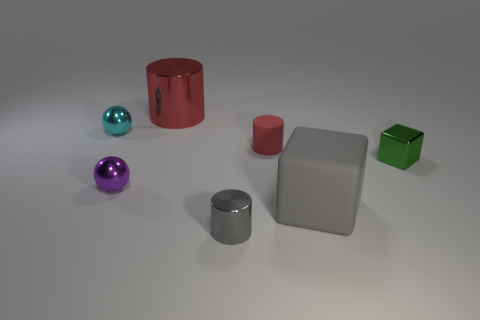Add 3 gray rubber objects. How many objects exist? 10 Subtract all blocks. How many objects are left? 5 Subtract 0 brown spheres. How many objects are left? 7 Subtract all tiny purple metallic things. Subtract all tiny purple metal balls. How many objects are left? 5 Add 1 small purple things. How many small purple things are left? 2 Add 3 big yellow rubber cylinders. How many big yellow rubber cylinders exist? 3 